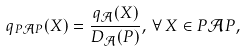Convert formula to latex. <formula><loc_0><loc_0><loc_500><loc_500>q _ { P \mathcal { A } P } ( X ) = \frac { q _ { \mathcal { A } } ( X ) } { D _ { \mathcal { A } } ( P ) } , \, \forall \, X \in P \mathcal { A } P ,</formula> 